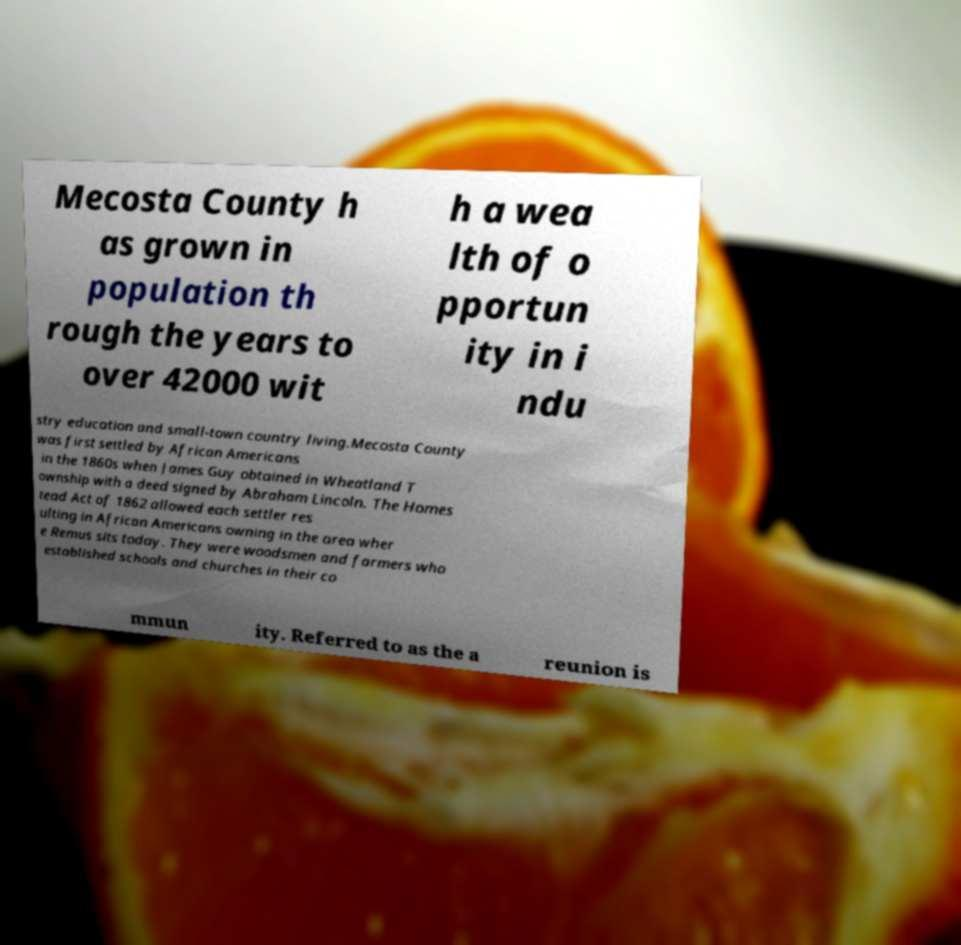Could you extract and type out the text from this image? Mecosta County h as grown in population th rough the years to over 42000 wit h a wea lth of o pportun ity in i ndu stry education and small-town country living.Mecosta County was first settled by African Americans in the 1860s when James Guy obtained in Wheatland T ownship with a deed signed by Abraham Lincoln. The Homes tead Act of 1862 allowed each settler res ulting in African Americans owning in the area wher e Remus sits today. They were woodsmen and farmers who established schools and churches in their co mmun ity. Referred to as the a reunion is 